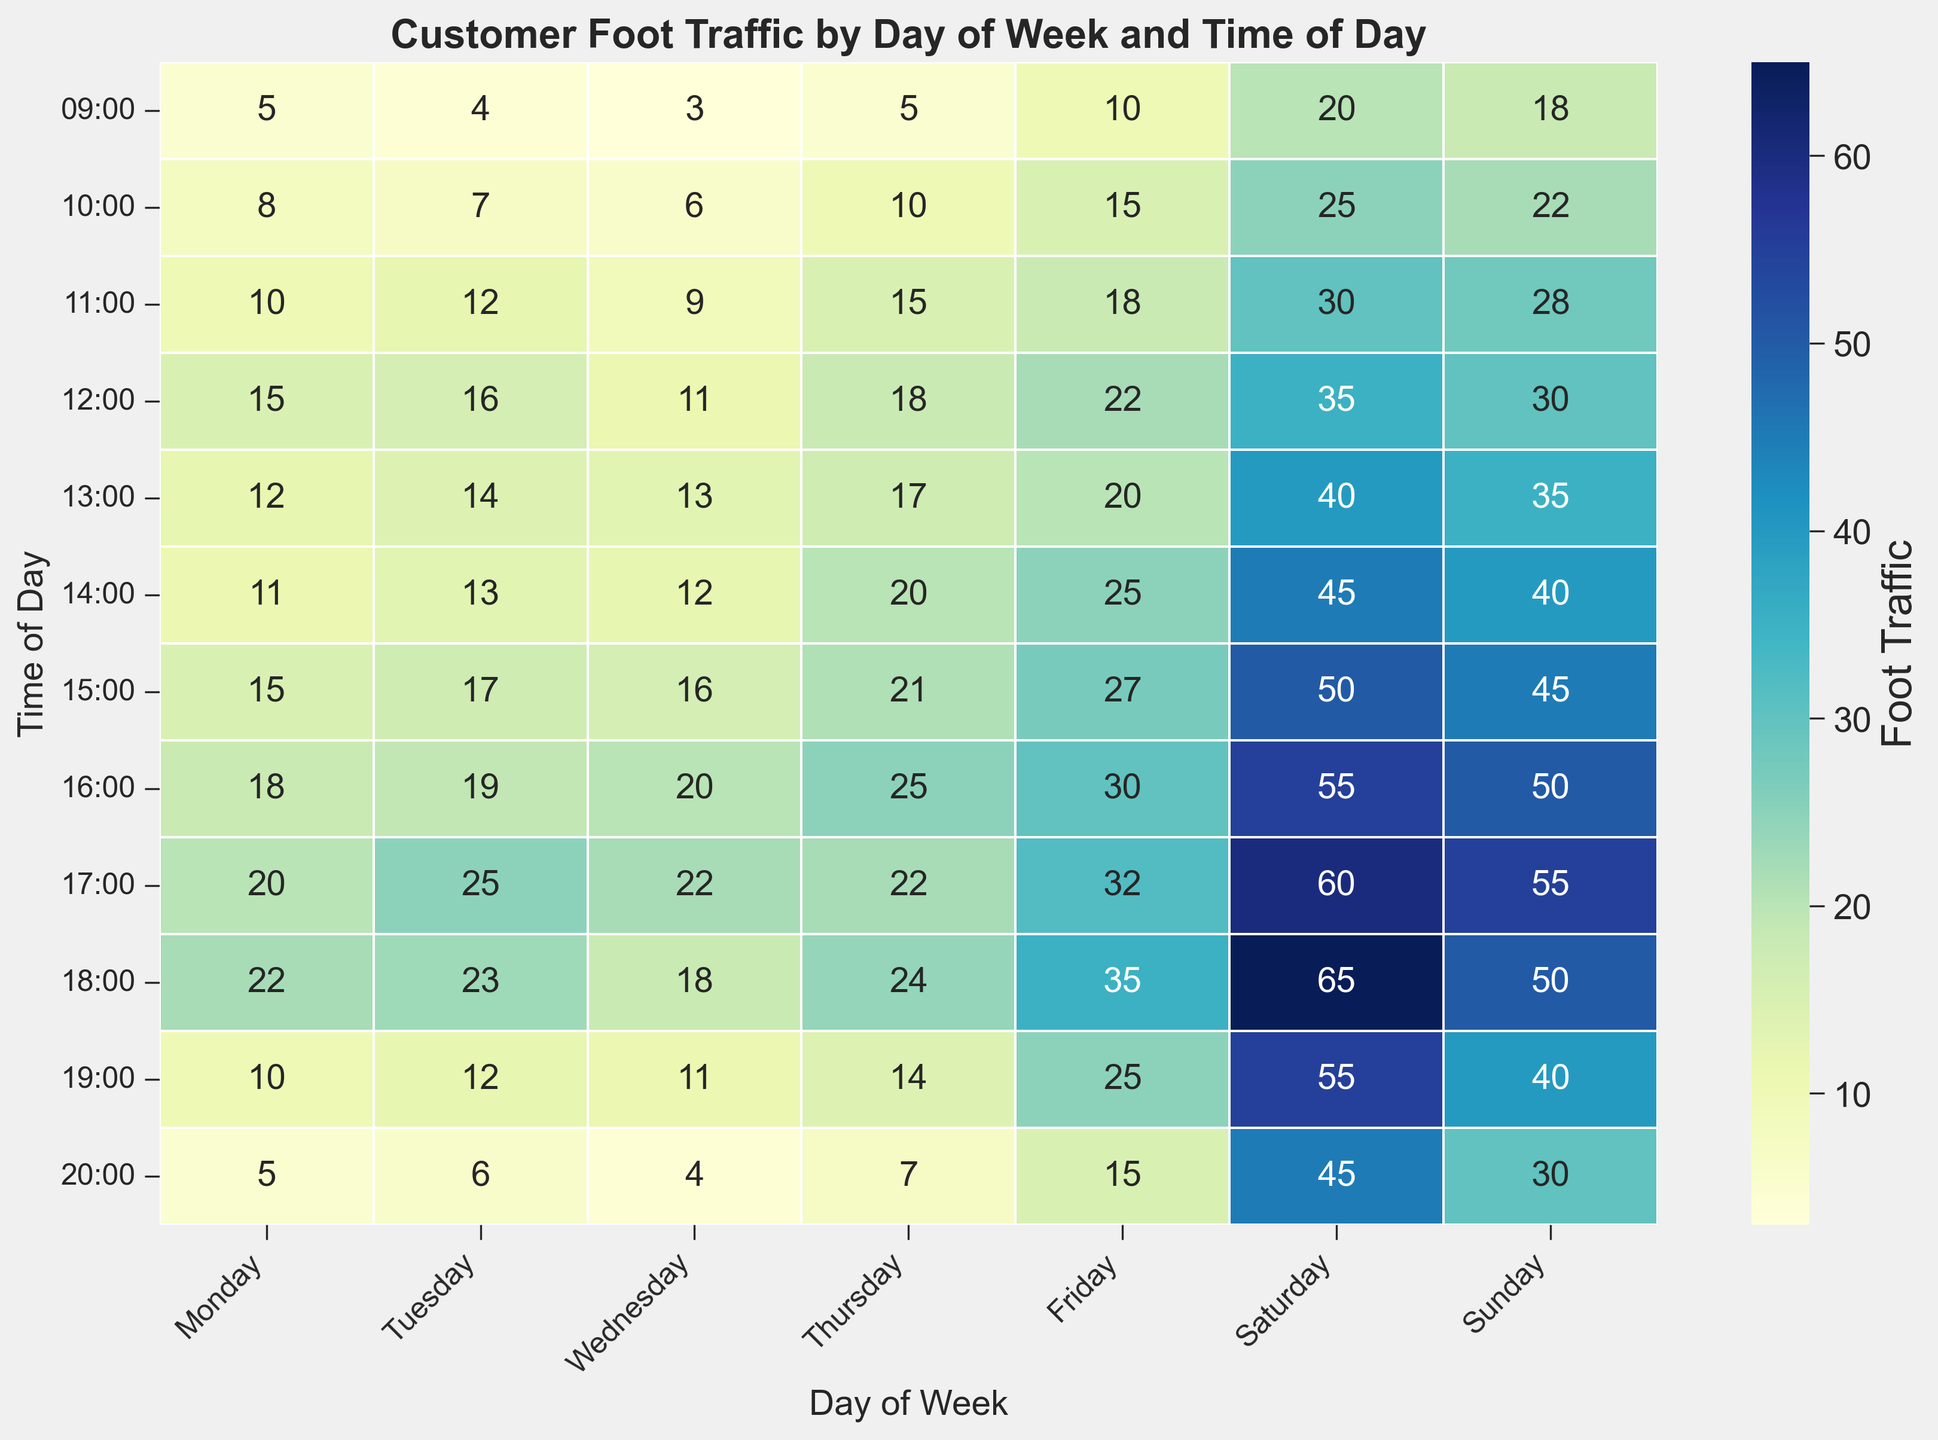Which day has the highest foot traffic at 17:00? Look at the heatmap and find the cell corresponding to 17:00 for each day. The day with the darkest color represents the highest foot traffic. Thursday and Friday at 17:00 both have high values, but Friday has 32 which is higher.
Answer: Friday Which day has the lowest foot traffic at 09:00? Observe the cells corresponding to 09:00 for each day. The day with the lightest color at 09:00 is Wednesday.
Answer: Wednesday On what day and time is the peak foot traffic observed? Identify the darkest cell in the heatmap, which represents the maximum foot traffic. This cell is at 18:00 on Saturday.
Answer: Saturday, 18:00 What is the difference in foot traffic between Monday at 18:00 and Wednesday at the same time? Locate the cells for Monday at 18:00 and Wednesday at 18:00, with values 22 and 18 respectively. The difference is 22 - 18 = 4.
Answer: 4 During which hour of the week does the foot traffic increase the most from the previous hour? Analyze each pair of consecutive hours across all days. The largest increase is from 16:00 to 17:00 on Saturday, where the foot traffic increases from 55 to 60, a difference of 5.
Answer: Saturday, 16:00 - 17:00 What is the total foot traffic for the entire week at 15:00? Sum the values of the cells corresponding to 15:00 across all days: 15 + 17 + 16 + 21 + 27 + 50 + 45 = 191.
Answer: 191 Which day has the most consistent (least variation) foot traffic throughout the day? Average the foot traffic for each day, then determine the standard deviation to find the most consistent. Here, we'll just approximate by looking for the least variation visually in color intensity. Wednesday seems relatively consistent with values ranging between 3 and 22.
Answer: Wednesday How does the foot traffic on a typical Monday afternoon (12:00 to 18:00) compare to a typical Thursday afternoon? Calculate the average foot traffic from 12:00 to 18:00 for both days. Monday: (15 + 12 + 11 + 15 + 18 + 20 + 22)/6 = 15.5; Thursday: (18 + 17 + 20 + 21 + 25 + 22 + 24)/6 = 20.5.
Answer: Thursday has higher traffic on average What time of day typically sees the lowest foot traffic on Sundays? Look at each time slot for Sunday and find the lightest cell. The lowest foot traffic is at 09:00 with a value of 18.
Answer: 09:00 